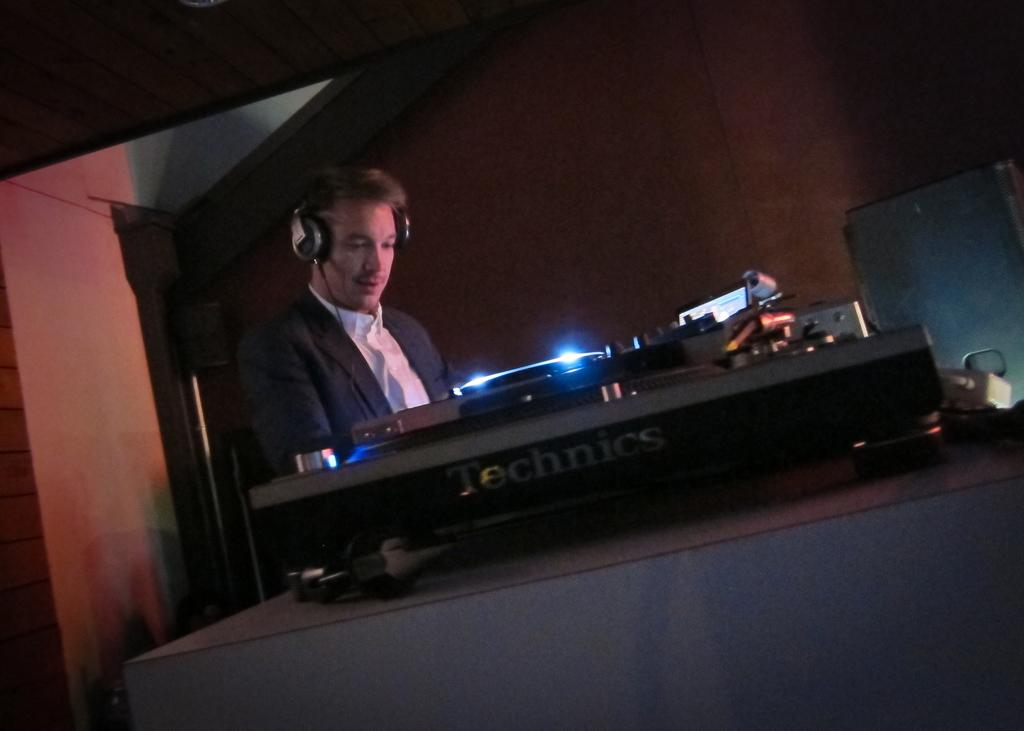<image>
Share a concise interpretation of the image provided. A man works on DJ equipment that says Technics on the side. 